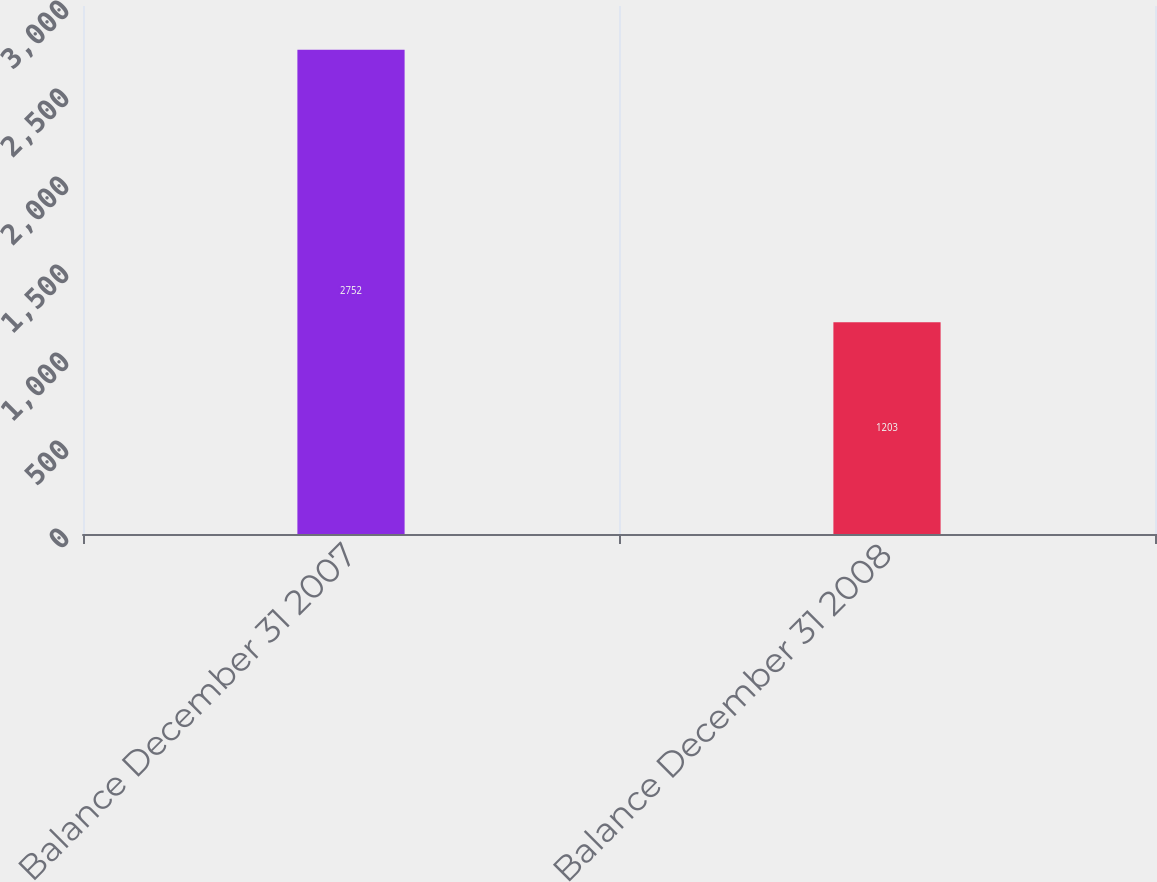Convert chart. <chart><loc_0><loc_0><loc_500><loc_500><bar_chart><fcel>Balance December 31 2007<fcel>Balance December 31 2008<nl><fcel>2752<fcel>1203<nl></chart> 